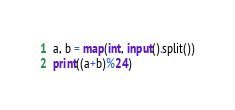Convert code to text. <code><loc_0><loc_0><loc_500><loc_500><_Python_>a, b = map(int, input().split())
print((a+b)%24)</code> 